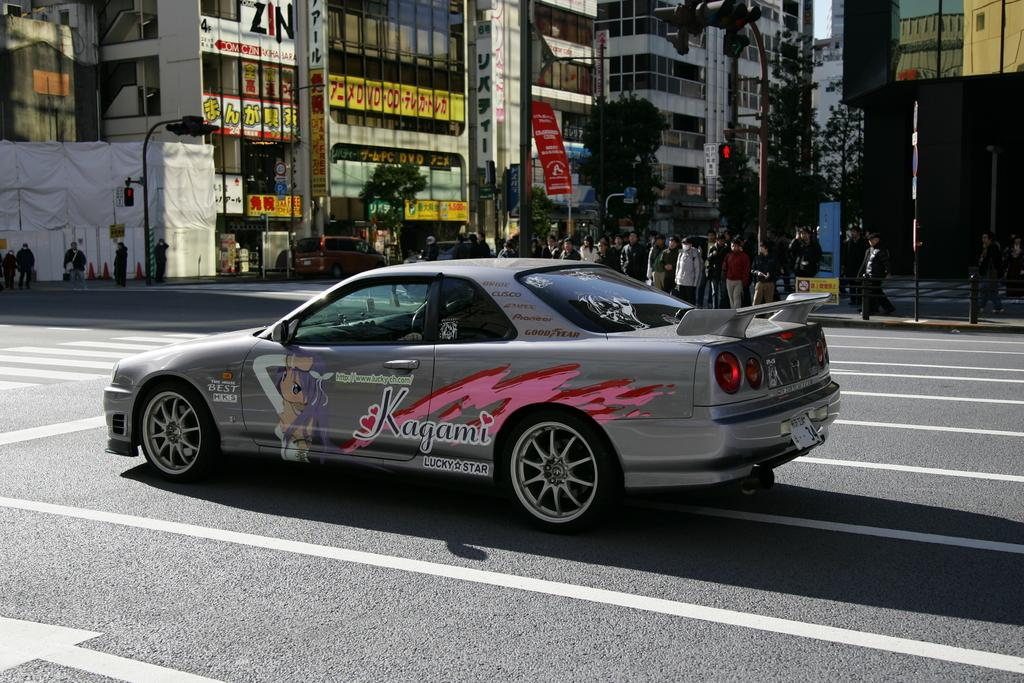What is the main subject of the image? The main subject of the image is a car on the road. What can be seen in the background of the image? In the background of the image, there are a group of people, trees, buildings, poles, and hoardings. Are there any traffic control devices visible in the image? Yes, traffic lights are visible in the image. How many geese are crossing the road in the image? There are no geese present in the image. What type of chickens can be seen walking on the sidewalk in the image? There are no chickens present in the image. 